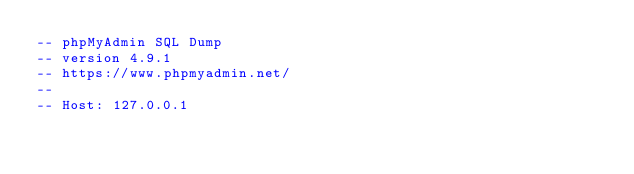<code> <loc_0><loc_0><loc_500><loc_500><_SQL_>-- phpMyAdmin SQL Dump
-- version 4.9.1
-- https://www.phpmyadmin.net/
--
-- Host: 127.0.0.1</code> 